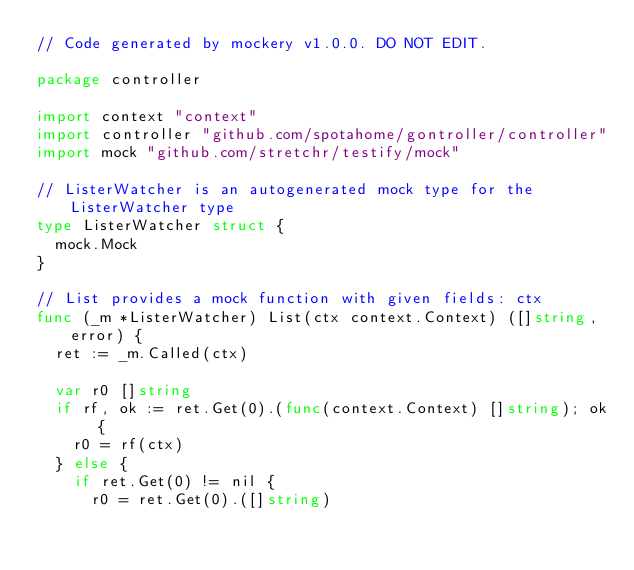Convert code to text. <code><loc_0><loc_0><loc_500><loc_500><_Go_>// Code generated by mockery v1.0.0. DO NOT EDIT.

package controller

import context "context"
import controller "github.com/spotahome/gontroller/controller"
import mock "github.com/stretchr/testify/mock"

// ListerWatcher is an autogenerated mock type for the ListerWatcher type
type ListerWatcher struct {
	mock.Mock
}

// List provides a mock function with given fields: ctx
func (_m *ListerWatcher) List(ctx context.Context) ([]string, error) {
	ret := _m.Called(ctx)

	var r0 []string
	if rf, ok := ret.Get(0).(func(context.Context) []string); ok {
		r0 = rf(ctx)
	} else {
		if ret.Get(0) != nil {
			r0 = ret.Get(0).([]string)</code> 